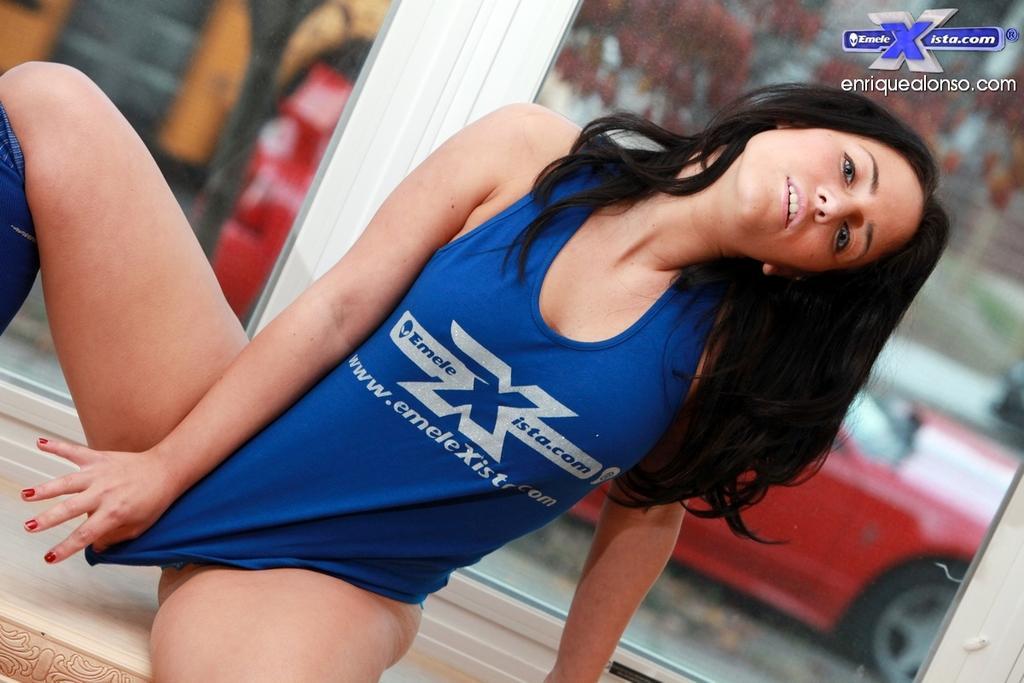In one or two sentences, can you explain what this image depicts? In this picture we can see a woman sitting. There are a few glass objects at the back of this woman. Through these glass objects, we can see a vehicle and other objects in the background. Background is blurry. We can see some text in the top right. 